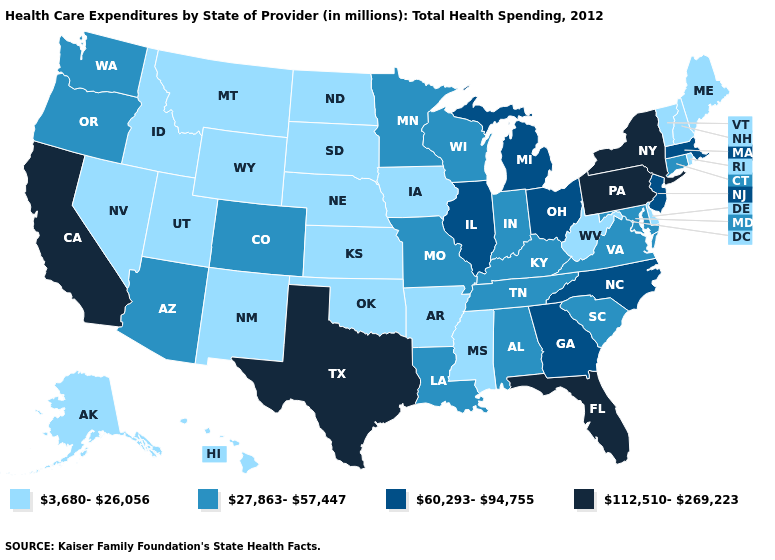What is the highest value in the USA?
Write a very short answer. 112,510-269,223. Among the states that border Alabama , does Mississippi have the lowest value?
Answer briefly. Yes. Name the states that have a value in the range 3,680-26,056?
Write a very short answer. Alaska, Arkansas, Delaware, Hawaii, Idaho, Iowa, Kansas, Maine, Mississippi, Montana, Nebraska, Nevada, New Hampshire, New Mexico, North Dakota, Oklahoma, Rhode Island, South Dakota, Utah, Vermont, West Virginia, Wyoming. Does South Carolina have a higher value than Oklahoma?
Concise answer only. Yes. What is the highest value in the USA?
Quick response, please. 112,510-269,223. Name the states that have a value in the range 27,863-57,447?
Write a very short answer. Alabama, Arizona, Colorado, Connecticut, Indiana, Kentucky, Louisiana, Maryland, Minnesota, Missouri, Oregon, South Carolina, Tennessee, Virginia, Washington, Wisconsin. Does the map have missing data?
Answer briefly. No. Which states have the lowest value in the USA?
Quick response, please. Alaska, Arkansas, Delaware, Hawaii, Idaho, Iowa, Kansas, Maine, Mississippi, Montana, Nebraska, Nevada, New Hampshire, New Mexico, North Dakota, Oklahoma, Rhode Island, South Dakota, Utah, Vermont, West Virginia, Wyoming. Does Pennsylvania have the lowest value in the Northeast?
Quick response, please. No. What is the value of Tennessee?
Short answer required. 27,863-57,447. Does the first symbol in the legend represent the smallest category?
Keep it brief. Yes. Does the map have missing data?
Short answer required. No. Name the states that have a value in the range 27,863-57,447?
Give a very brief answer. Alabama, Arizona, Colorado, Connecticut, Indiana, Kentucky, Louisiana, Maryland, Minnesota, Missouri, Oregon, South Carolina, Tennessee, Virginia, Washington, Wisconsin. Which states have the lowest value in the USA?
Be succinct. Alaska, Arkansas, Delaware, Hawaii, Idaho, Iowa, Kansas, Maine, Mississippi, Montana, Nebraska, Nevada, New Hampshire, New Mexico, North Dakota, Oklahoma, Rhode Island, South Dakota, Utah, Vermont, West Virginia, Wyoming. Name the states that have a value in the range 3,680-26,056?
Quick response, please. Alaska, Arkansas, Delaware, Hawaii, Idaho, Iowa, Kansas, Maine, Mississippi, Montana, Nebraska, Nevada, New Hampshire, New Mexico, North Dakota, Oklahoma, Rhode Island, South Dakota, Utah, Vermont, West Virginia, Wyoming. 